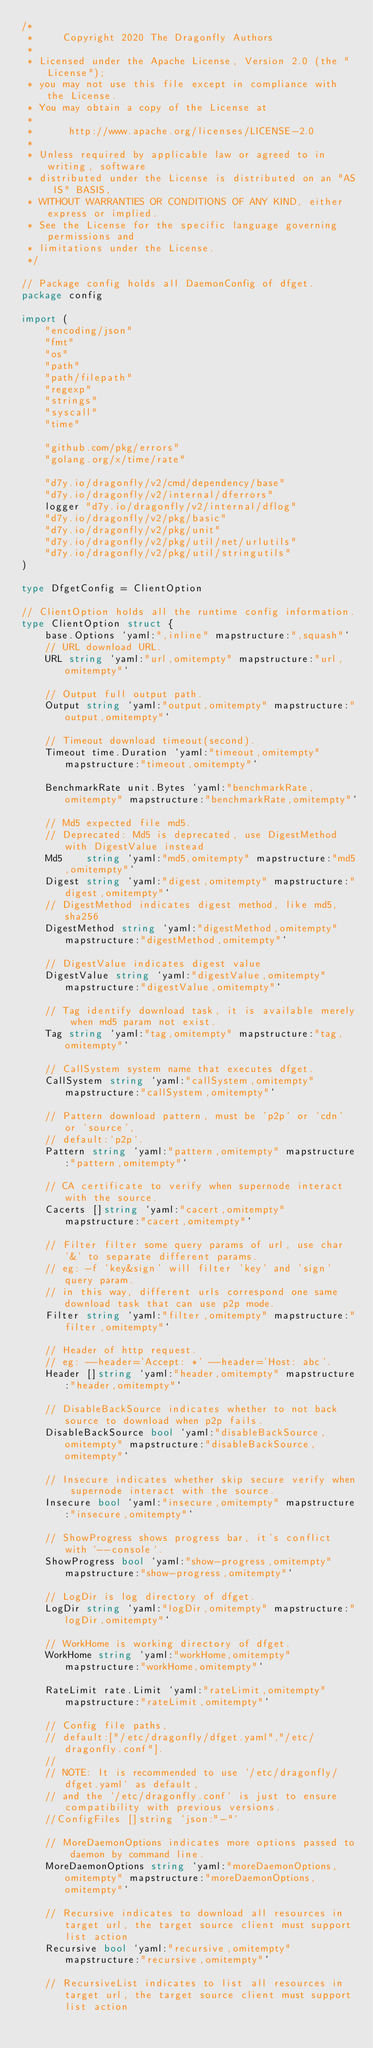<code> <loc_0><loc_0><loc_500><loc_500><_Go_>/*
 *     Copyright 2020 The Dragonfly Authors
 *
 * Licensed under the Apache License, Version 2.0 (the "License");
 * you may not use this file except in compliance with the License.
 * You may obtain a copy of the License at
 *
 *      http://www.apache.org/licenses/LICENSE-2.0
 *
 * Unless required by applicable law or agreed to in writing, software
 * distributed under the License is distributed on an "AS IS" BASIS,
 * WITHOUT WARRANTIES OR CONDITIONS OF ANY KIND, either express or implied.
 * See the License for the specific language governing permissions and
 * limitations under the License.
 */

// Package config holds all DaemonConfig of dfget.
package config

import (
	"encoding/json"
	"fmt"
	"os"
	"path"
	"path/filepath"
	"regexp"
	"strings"
	"syscall"
	"time"

	"github.com/pkg/errors"
	"golang.org/x/time/rate"

	"d7y.io/dragonfly/v2/cmd/dependency/base"
	"d7y.io/dragonfly/v2/internal/dferrors"
	logger "d7y.io/dragonfly/v2/internal/dflog"
	"d7y.io/dragonfly/v2/pkg/basic"
	"d7y.io/dragonfly/v2/pkg/unit"
	"d7y.io/dragonfly/v2/pkg/util/net/urlutils"
	"d7y.io/dragonfly/v2/pkg/util/stringutils"
)

type DfgetConfig = ClientOption

// ClientOption holds all the runtime config information.
type ClientOption struct {
	base.Options `yaml:",inline" mapstructure:",squash"`
	// URL download URL.
	URL string `yaml:"url,omitempty" mapstructure:"url,omitempty"`

	// Output full output path.
	Output string `yaml:"output,omitempty" mapstructure:"output,omitempty"`

	// Timeout download timeout(second).
	Timeout time.Duration `yaml:"timeout,omitempty" mapstructure:"timeout,omitempty"`

	BenchmarkRate unit.Bytes `yaml:"benchmarkRate,omitempty" mapstructure:"benchmarkRate,omitempty"`

	// Md5 expected file md5.
	// Deprecated: Md5 is deprecated, use DigestMethod with DigestValue instead
	Md5    string `yaml:"md5,omitempty" mapstructure:"md5,omitempty"`
	Digest string `yaml:"digest,omitempty" mapstructure:"digest,omitempty"`
	// DigestMethod indicates digest method, like md5, sha256
	DigestMethod string `yaml:"digestMethod,omitempty" mapstructure:"digestMethod,omitempty"`

	// DigestValue indicates digest value
	DigestValue string `yaml:"digestValue,omitempty" mapstructure:"digestValue,omitempty"`

	// Tag identify download task, it is available merely when md5 param not exist.
	Tag string `yaml:"tag,omitempty" mapstructure:"tag,omitempty"`

	// CallSystem system name that executes dfget.
	CallSystem string `yaml:"callSystem,omitempty" mapstructure:"callSystem,omitempty"`

	// Pattern download pattern, must be 'p2p' or 'cdn' or 'source',
	// default:`p2p`.
	Pattern string `yaml:"pattern,omitempty" mapstructure:"pattern,omitempty"`

	// CA certificate to verify when supernode interact with the source.
	Cacerts []string `yaml:"cacert,omitempty" mapstructure:"cacert,omitempty"`

	// Filter filter some query params of url, use char '&' to separate different params.
	// eg: -f 'key&sign' will filter 'key' and 'sign' query param.
	// in this way, different urls correspond one same download task that can use p2p mode.
	Filter string `yaml:"filter,omitempty" mapstructure:"filter,omitempty"`

	// Header of http request.
	// eg: --header='Accept: *' --header='Host: abc'.
	Header []string `yaml:"header,omitempty" mapstructure:"header,omitempty"`

	// DisableBackSource indicates whether to not back source to download when p2p fails.
	DisableBackSource bool `yaml:"disableBackSource,omitempty" mapstructure:"disableBackSource,omitempty"`

	// Insecure indicates whether skip secure verify when supernode interact with the source.
	Insecure bool `yaml:"insecure,omitempty" mapstructure:"insecure,omitempty"`

	// ShowProgress shows progress bar, it's conflict with `--console`.
	ShowProgress bool `yaml:"show-progress,omitempty" mapstructure:"show-progress,omitempty"`

	// LogDir is log directory of dfget.
	LogDir string `yaml:"logDir,omitempty" mapstructure:"logDir,omitempty"`

	// WorkHome is working directory of dfget.
	WorkHome string `yaml:"workHome,omitempty" mapstructure:"workHome,omitempty"`

	RateLimit rate.Limit `yaml:"rateLimit,omitempty" mapstructure:"rateLimit,omitempty"`

	// Config file paths,
	// default:["/etc/dragonfly/dfget.yaml","/etc/dragonfly.conf"].
	//
	// NOTE: It is recommended to use `/etc/dragonfly/dfget.yaml` as default,
	// and the `/etc/dragonfly.conf` is just to ensure compatibility with previous versions.
	//ConfigFiles []string `json:"-"`

	// MoreDaemonOptions indicates more options passed to daemon by command line.
	MoreDaemonOptions string `yaml:"moreDaemonOptions,omitempty" mapstructure:"moreDaemonOptions,omitempty"`

	// Recursive indicates to download all resources in target url, the target source client must support list action
	Recursive bool `yaml:"recursive,omitempty" mapstructure:"recursive,omitempty"`

	// RecursiveList indicates to list all resources in target url, the target source client must support list action</code> 